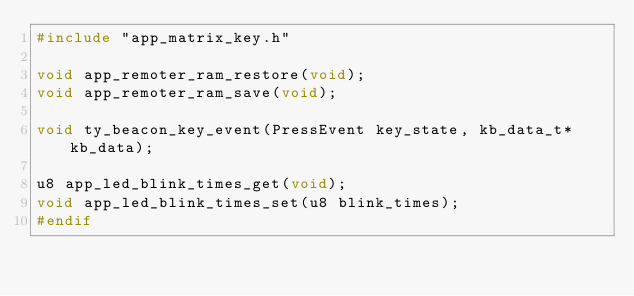Convert code to text. <code><loc_0><loc_0><loc_500><loc_500><_C_>#include "app_matrix_key.h"

void app_remoter_ram_restore(void);
void app_remoter_ram_save(void);

void ty_beacon_key_event(PressEvent key_state, kb_data_t* kb_data);

u8 app_led_blink_times_get(void);
void app_led_blink_times_set(u8 blink_times);
#endif
</code> 